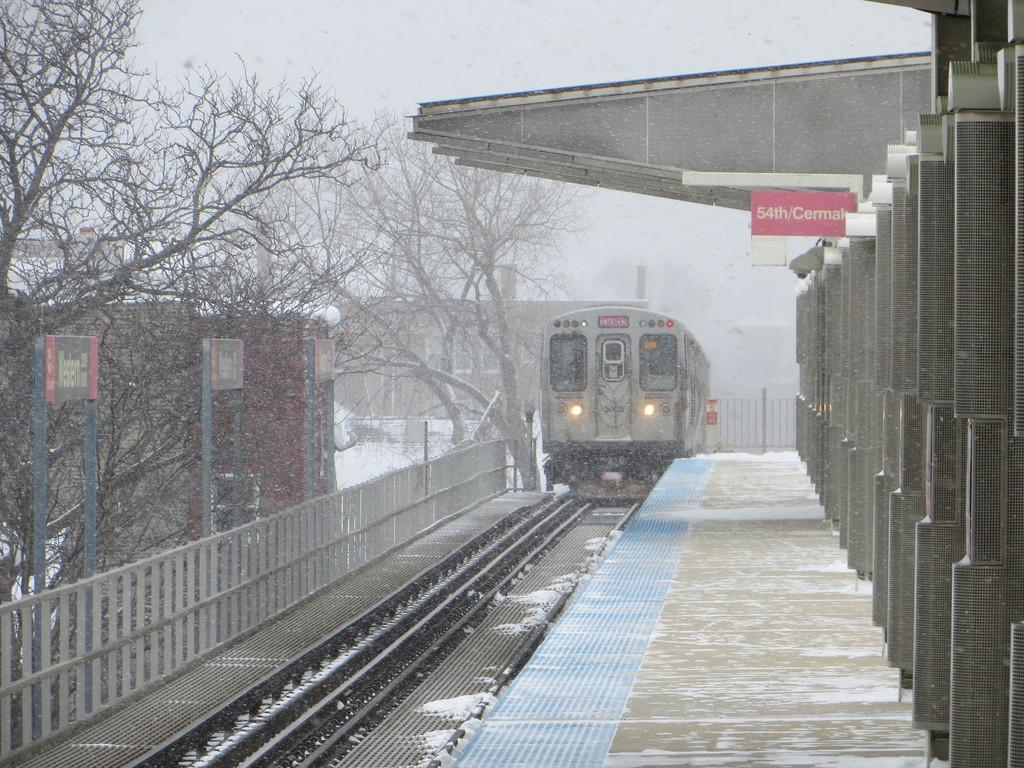<image>
Provide a brief description of the given image. A train pulling up to the Western station, with a sign on an overhang that says 54th/Cermak. 